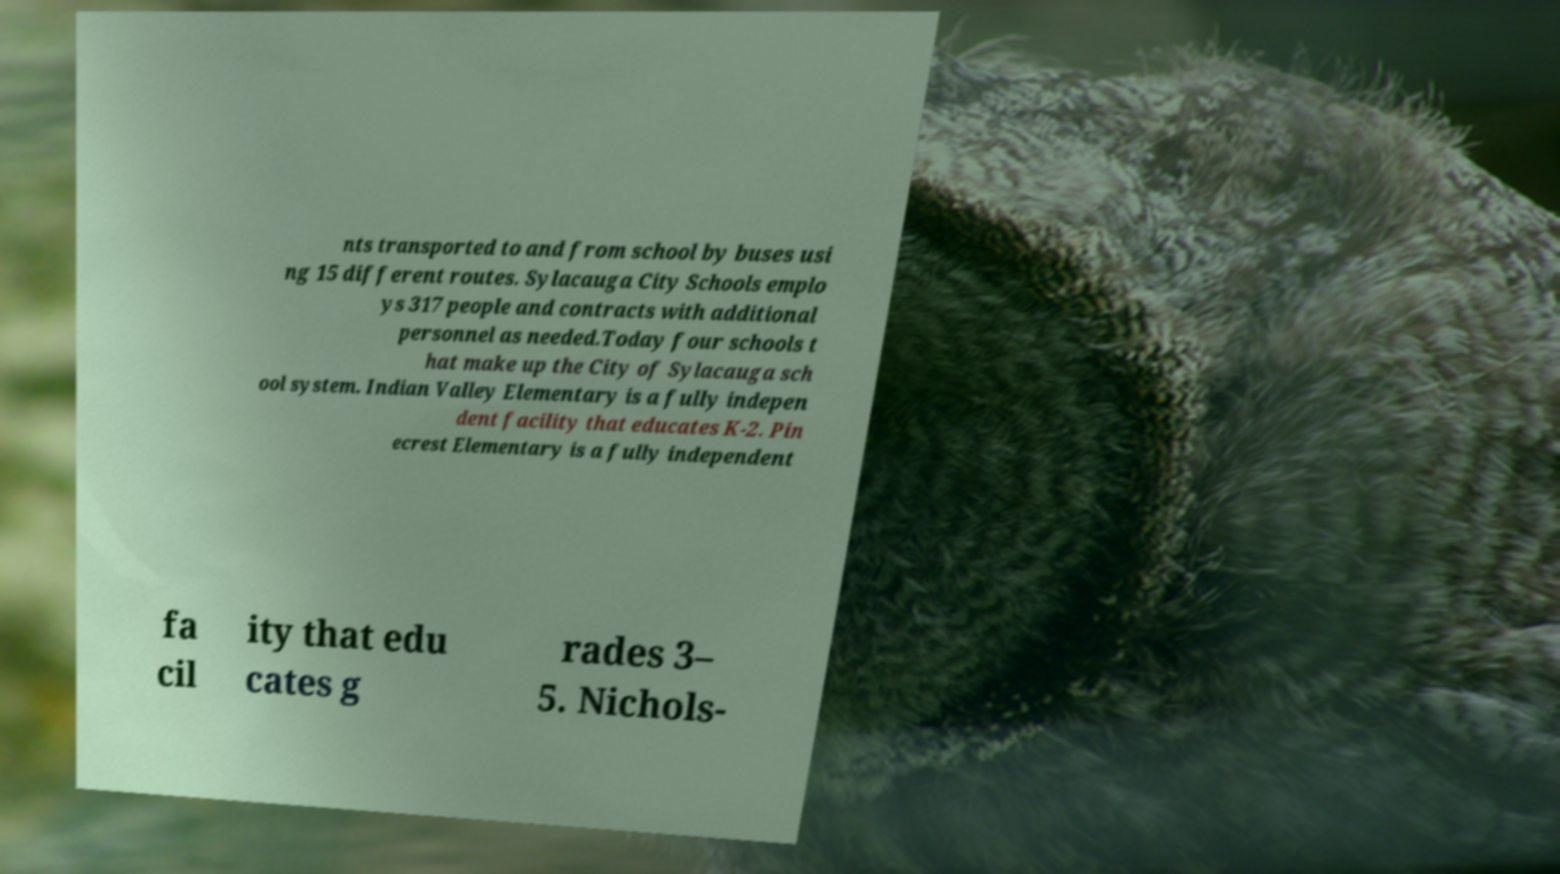There's text embedded in this image that I need extracted. Can you transcribe it verbatim? nts transported to and from school by buses usi ng 15 different routes. Sylacauga City Schools emplo ys 317 people and contracts with additional personnel as needed.Today four schools t hat make up the City of Sylacauga sch ool system. Indian Valley Elementary is a fully indepen dent facility that educates K-2. Pin ecrest Elementary is a fully independent fa cil ity that edu cates g rades 3– 5. Nichols- 